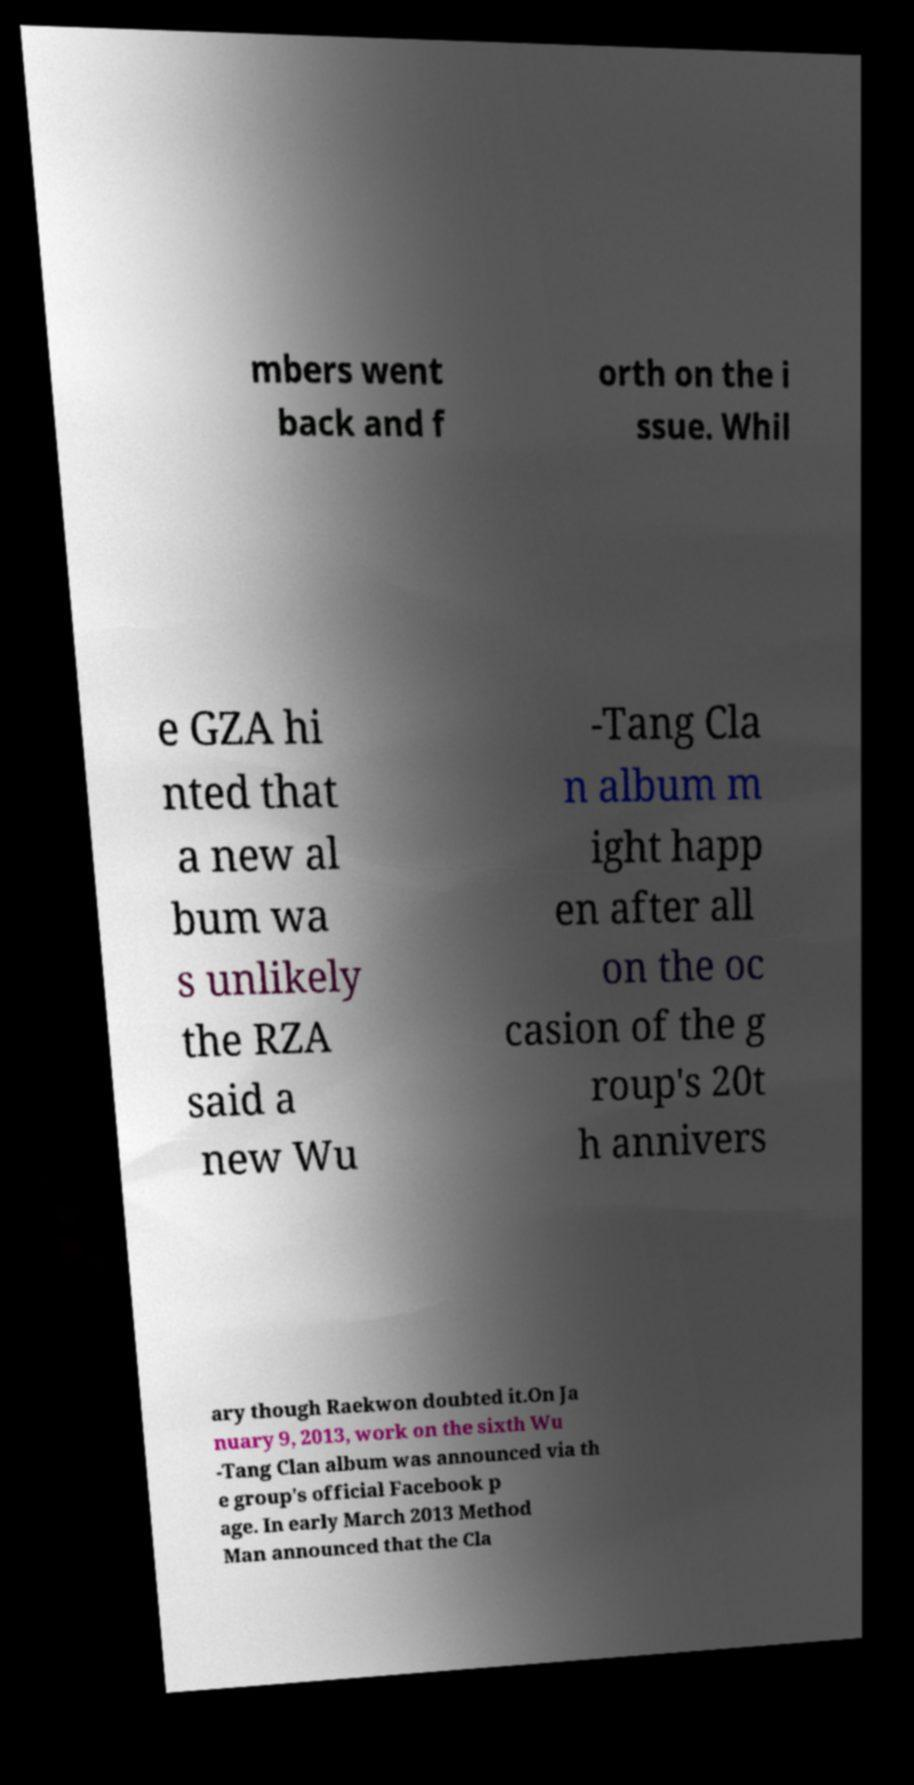Can you read and provide the text displayed in the image?This photo seems to have some interesting text. Can you extract and type it out for me? mbers went back and f orth on the i ssue. Whil e GZA hi nted that a new al bum wa s unlikely the RZA said a new Wu -Tang Cla n album m ight happ en after all on the oc casion of the g roup's 20t h annivers ary though Raekwon doubted it.On Ja nuary 9, 2013, work on the sixth Wu -Tang Clan album was announced via th e group's official Facebook p age. In early March 2013 Method Man announced that the Cla 